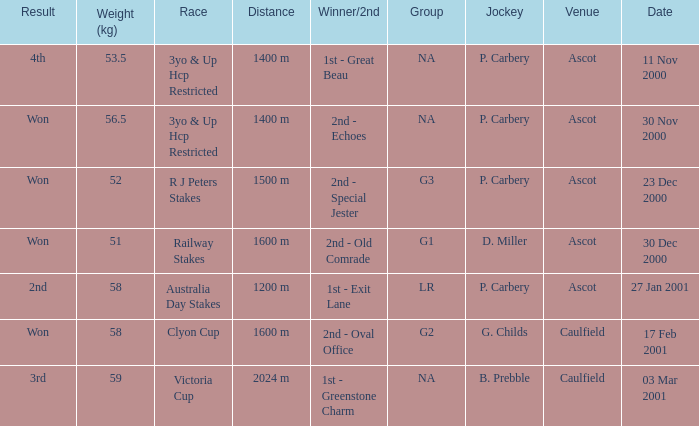What group info is available for the 56.5 kg weight? NA. 